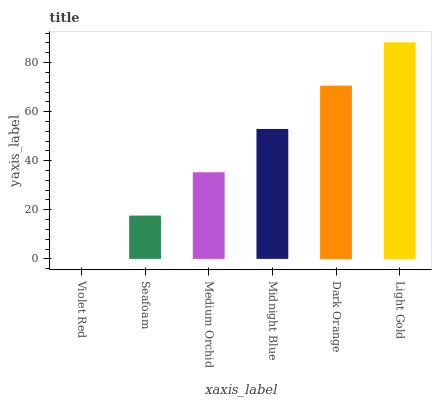Is Violet Red the minimum?
Answer yes or no. Yes. Is Light Gold the maximum?
Answer yes or no. Yes. Is Seafoam the minimum?
Answer yes or no. No. Is Seafoam the maximum?
Answer yes or no. No. Is Seafoam greater than Violet Red?
Answer yes or no. Yes. Is Violet Red less than Seafoam?
Answer yes or no. Yes. Is Violet Red greater than Seafoam?
Answer yes or no. No. Is Seafoam less than Violet Red?
Answer yes or no. No. Is Midnight Blue the high median?
Answer yes or no. Yes. Is Medium Orchid the low median?
Answer yes or no. Yes. Is Dark Orange the high median?
Answer yes or no. No. Is Light Gold the low median?
Answer yes or no. No. 